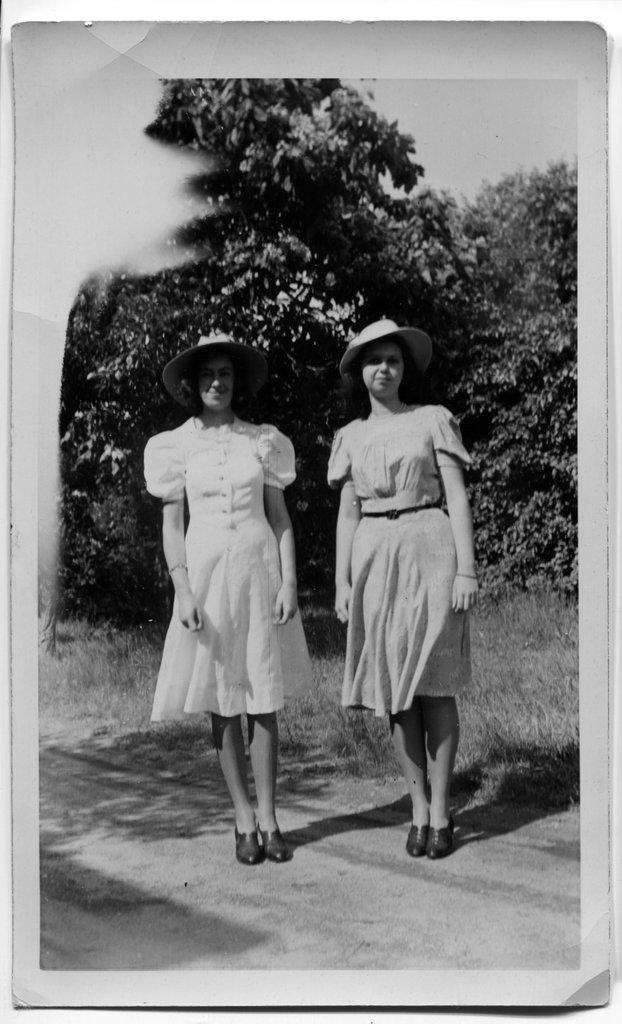How many people are in the image? There are two women in the image. What are the women wearing on their heads? The women are wearing caps. What type of vegetation can be seen behind the women? There are trees visible behind the women. What is the color scheme of the image? The photography is in black and white. What type of ground surface is visible in the image? There is grass visible in the image. What language are the women speaking in the image? The image does not provide any information about the language being spoken by the women. How far can the women see in the image? The image does not provide any information about the range of vision for the women. 